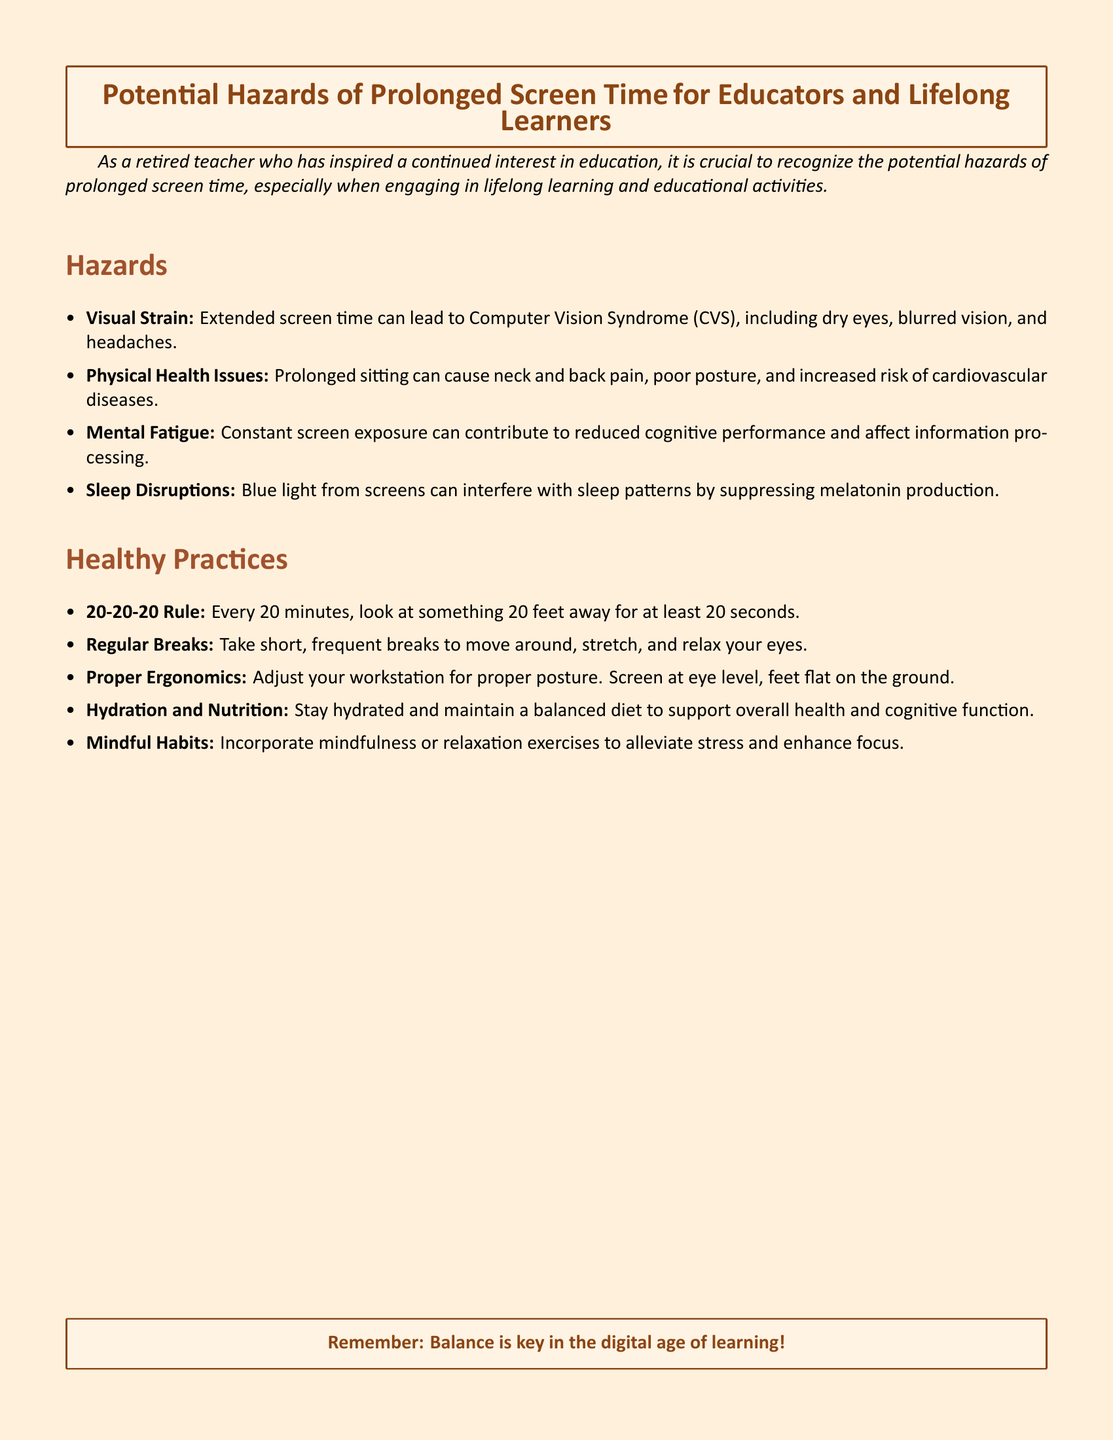What is the main subject of the document? The document mainly addresses the potential hazards of prolonged screen time, especially for educators and lifelong learners.
Answer: Potential Hazards of Prolonged Screen Time How many healthy practices are mentioned? The document lists a total of five healthy practices aimed at reducing the hazards of prolonged screen time.
Answer: Five What does the 20-20-20 Rule suggest? This rule advises looking at something 20 feet away for at least 20 seconds every 20 minutes to alleviate visual strain.
Answer: Look at something 20 feet away for 20 seconds What health issue is associated with prolonged sitting? The document states that prolonged sitting can lead to neck and back pain, poor posture, and other health concerns.
Answer: Neck and back pain What type of light interferes with sleep patterns? The document indicates that blue light emitted by screens can disrupt sleep by suppressing melatonin production.
Answer: Blue light What kind of exercises should be incorporated to relieve stress? Incorporating mindfulness or relaxation exercises can help alleviate stress and enhance focus.
Answer: Mindfulness or relaxation exercises What color is the title? The title color specified in the document is a particular shade related to the theme of warnings.
Answer: Brown 